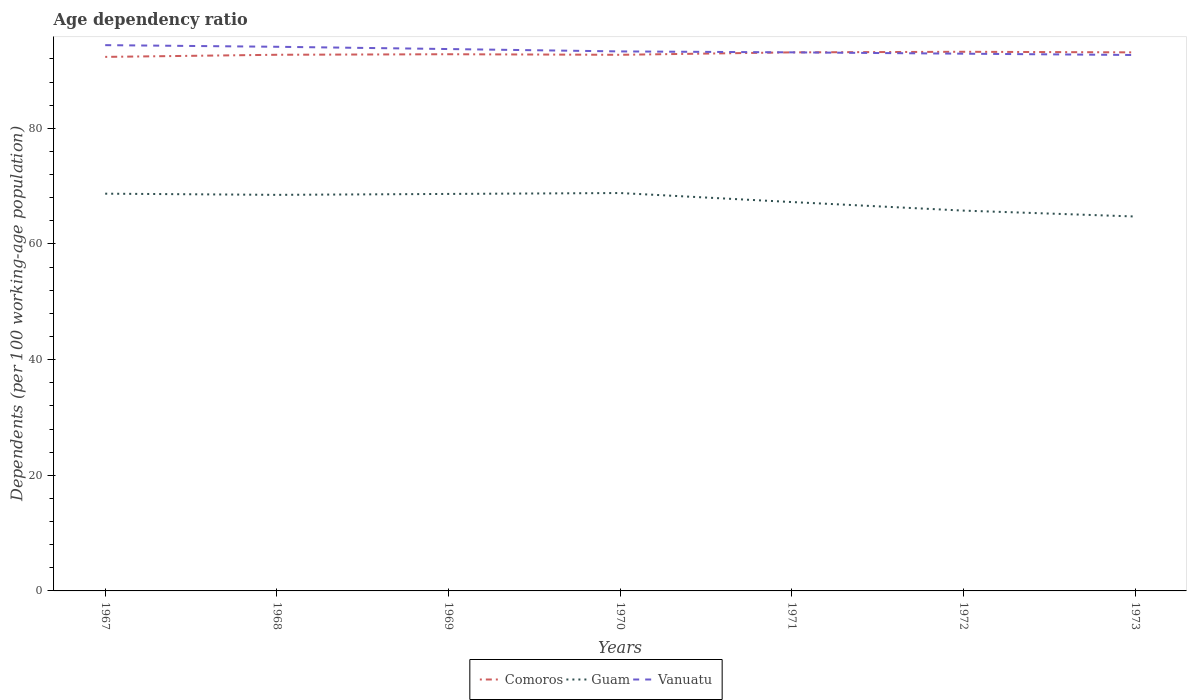How many different coloured lines are there?
Your answer should be compact. 3. Does the line corresponding to Comoros intersect with the line corresponding to Guam?
Offer a very short reply. No. Is the number of lines equal to the number of legend labels?
Offer a very short reply. Yes. Across all years, what is the maximum age dependency ratio in in Vanuatu?
Your response must be concise. 92.67. In which year was the age dependency ratio in in Vanuatu maximum?
Ensure brevity in your answer.  1973. What is the total age dependency ratio in in Guam in the graph?
Keep it short and to the point. 1.24. What is the difference between the highest and the second highest age dependency ratio in in Guam?
Offer a terse response. 4.06. How many years are there in the graph?
Your answer should be very brief. 7. Are the values on the major ticks of Y-axis written in scientific E-notation?
Ensure brevity in your answer.  No. Does the graph contain grids?
Give a very brief answer. No. What is the title of the graph?
Offer a very short reply. Age dependency ratio. Does "Norway" appear as one of the legend labels in the graph?
Your answer should be compact. No. What is the label or title of the X-axis?
Make the answer very short. Years. What is the label or title of the Y-axis?
Offer a terse response. Dependents (per 100 working-age population). What is the Dependents (per 100 working-age population) of Comoros in 1967?
Give a very brief answer. 92.35. What is the Dependents (per 100 working-age population) of Guam in 1967?
Make the answer very short. 68.69. What is the Dependents (per 100 working-age population) in Vanuatu in 1967?
Give a very brief answer. 94.38. What is the Dependents (per 100 working-age population) in Comoros in 1968?
Provide a short and direct response. 92.72. What is the Dependents (per 100 working-age population) in Guam in 1968?
Your answer should be very brief. 68.49. What is the Dependents (per 100 working-age population) in Vanuatu in 1968?
Your response must be concise. 94.1. What is the Dependents (per 100 working-age population) in Comoros in 1969?
Offer a very short reply. 92.81. What is the Dependents (per 100 working-age population) in Guam in 1969?
Ensure brevity in your answer.  68.65. What is the Dependents (per 100 working-age population) of Vanuatu in 1969?
Your answer should be very brief. 93.71. What is the Dependents (per 100 working-age population) in Comoros in 1970?
Provide a short and direct response. 92.71. What is the Dependents (per 100 working-age population) of Guam in 1970?
Offer a very short reply. 68.81. What is the Dependents (per 100 working-age population) of Vanuatu in 1970?
Your response must be concise. 93.29. What is the Dependents (per 100 working-age population) of Comoros in 1971?
Your response must be concise. 93.13. What is the Dependents (per 100 working-age population) of Guam in 1971?
Provide a succinct answer. 67.25. What is the Dependents (per 100 working-age population) of Vanuatu in 1971?
Offer a very short reply. 93.13. What is the Dependents (per 100 working-age population) in Comoros in 1972?
Ensure brevity in your answer.  93.23. What is the Dependents (per 100 working-age population) in Guam in 1972?
Keep it short and to the point. 65.77. What is the Dependents (per 100 working-age population) in Vanuatu in 1972?
Keep it short and to the point. 92.9. What is the Dependents (per 100 working-age population) in Comoros in 1973?
Keep it short and to the point. 93.13. What is the Dependents (per 100 working-age population) in Guam in 1973?
Offer a terse response. 64.75. What is the Dependents (per 100 working-age population) of Vanuatu in 1973?
Your answer should be compact. 92.67. Across all years, what is the maximum Dependents (per 100 working-age population) of Comoros?
Offer a very short reply. 93.23. Across all years, what is the maximum Dependents (per 100 working-age population) in Guam?
Provide a short and direct response. 68.81. Across all years, what is the maximum Dependents (per 100 working-age population) in Vanuatu?
Keep it short and to the point. 94.38. Across all years, what is the minimum Dependents (per 100 working-age population) in Comoros?
Ensure brevity in your answer.  92.35. Across all years, what is the minimum Dependents (per 100 working-age population) in Guam?
Keep it short and to the point. 64.75. Across all years, what is the minimum Dependents (per 100 working-age population) in Vanuatu?
Keep it short and to the point. 92.67. What is the total Dependents (per 100 working-age population) of Comoros in the graph?
Your answer should be compact. 650.08. What is the total Dependents (per 100 working-age population) in Guam in the graph?
Keep it short and to the point. 472.41. What is the total Dependents (per 100 working-age population) of Vanuatu in the graph?
Offer a terse response. 654.19. What is the difference between the Dependents (per 100 working-age population) in Comoros in 1967 and that in 1968?
Make the answer very short. -0.37. What is the difference between the Dependents (per 100 working-age population) of Guam in 1967 and that in 1968?
Offer a very short reply. 0.2. What is the difference between the Dependents (per 100 working-age population) of Vanuatu in 1967 and that in 1968?
Make the answer very short. 0.28. What is the difference between the Dependents (per 100 working-age population) of Comoros in 1967 and that in 1969?
Provide a short and direct response. -0.46. What is the difference between the Dependents (per 100 working-age population) of Guam in 1967 and that in 1969?
Provide a short and direct response. 0.04. What is the difference between the Dependents (per 100 working-age population) in Vanuatu in 1967 and that in 1969?
Your answer should be very brief. 0.67. What is the difference between the Dependents (per 100 working-age population) of Comoros in 1967 and that in 1970?
Keep it short and to the point. -0.36. What is the difference between the Dependents (per 100 working-age population) in Guam in 1967 and that in 1970?
Provide a succinct answer. -0.11. What is the difference between the Dependents (per 100 working-age population) of Vanuatu in 1967 and that in 1970?
Make the answer very short. 1.09. What is the difference between the Dependents (per 100 working-age population) in Comoros in 1967 and that in 1971?
Your response must be concise. -0.78. What is the difference between the Dependents (per 100 working-age population) of Guam in 1967 and that in 1971?
Give a very brief answer. 1.45. What is the difference between the Dependents (per 100 working-age population) of Vanuatu in 1967 and that in 1971?
Provide a succinct answer. 1.25. What is the difference between the Dependents (per 100 working-age population) in Comoros in 1967 and that in 1972?
Keep it short and to the point. -0.88. What is the difference between the Dependents (per 100 working-age population) of Guam in 1967 and that in 1972?
Your answer should be compact. 2.93. What is the difference between the Dependents (per 100 working-age population) of Vanuatu in 1967 and that in 1972?
Give a very brief answer. 1.48. What is the difference between the Dependents (per 100 working-age population) in Comoros in 1967 and that in 1973?
Make the answer very short. -0.78. What is the difference between the Dependents (per 100 working-age population) of Guam in 1967 and that in 1973?
Your response must be concise. 3.95. What is the difference between the Dependents (per 100 working-age population) in Vanuatu in 1967 and that in 1973?
Your answer should be compact. 1.71. What is the difference between the Dependents (per 100 working-age population) in Comoros in 1968 and that in 1969?
Your response must be concise. -0.09. What is the difference between the Dependents (per 100 working-age population) in Guam in 1968 and that in 1969?
Make the answer very short. -0.16. What is the difference between the Dependents (per 100 working-age population) of Vanuatu in 1968 and that in 1969?
Keep it short and to the point. 0.39. What is the difference between the Dependents (per 100 working-age population) of Comoros in 1968 and that in 1970?
Offer a very short reply. 0.01. What is the difference between the Dependents (per 100 working-age population) of Guam in 1968 and that in 1970?
Give a very brief answer. -0.31. What is the difference between the Dependents (per 100 working-age population) of Vanuatu in 1968 and that in 1970?
Offer a terse response. 0.8. What is the difference between the Dependents (per 100 working-age population) of Comoros in 1968 and that in 1971?
Offer a terse response. -0.42. What is the difference between the Dependents (per 100 working-age population) of Guam in 1968 and that in 1971?
Give a very brief answer. 1.24. What is the difference between the Dependents (per 100 working-age population) of Vanuatu in 1968 and that in 1971?
Offer a terse response. 0.96. What is the difference between the Dependents (per 100 working-age population) in Comoros in 1968 and that in 1972?
Provide a short and direct response. -0.52. What is the difference between the Dependents (per 100 working-age population) of Guam in 1968 and that in 1972?
Your answer should be compact. 2.72. What is the difference between the Dependents (per 100 working-age population) in Vanuatu in 1968 and that in 1972?
Keep it short and to the point. 1.2. What is the difference between the Dependents (per 100 working-age population) of Comoros in 1968 and that in 1973?
Ensure brevity in your answer.  -0.41. What is the difference between the Dependents (per 100 working-age population) of Guam in 1968 and that in 1973?
Ensure brevity in your answer.  3.74. What is the difference between the Dependents (per 100 working-age population) in Vanuatu in 1968 and that in 1973?
Keep it short and to the point. 1.42. What is the difference between the Dependents (per 100 working-age population) in Comoros in 1969 and that in 1970?
Offer a terse response. 0.1. What is the difference between the Dependents (per 100 working-age population) of Guam in 1969 and that in 1970?
Keep it short and to the point. -0.16. What is the difference between the Dependents (per 100 working-age population) in Vanuatu in 1969 and that in 1970?
Offer a very short reply. 0.41. What is the difference between the Dependents (per 100 working-age population) of Comoros in 1969 and that in 1971?
Give a very brief answer. -0.32. What is the difference between the Dependents (per 100 working-age population) in Guam in 1969 and that in 1971?
Provide a short and direct response. 1.4. What is the difference between the Dependents (per 100 working-age population) of Vanuatu in 1969 and that in 1971?
Provide a short and direct response. 0.57. What is the difference between the Dependents (per 100 working-age population) in Comoros in 1969 and that in 1972?
Ensure brevity in your answer.  -0.42. What is the difference between the Dependents (per 100 working-age population) in Guam in 1969 and that in 1972?
Offer a very short reply. 2.88. What is the difference between the Dependents (per 100 working-age population) of Vanuatu in 1969 and that in 1972?
Your response must be concise. 0.8. What is the difference between the Dependents (per 100 working-age population) of Comoros in 1969 and that in 1973?
Your response must be concise. -0.32. What is the difference between the Dependents (per 100 working-age population) of Guam in 1969 and that in 1973?
Your answer should be very brief. 3.9. What is the difference between the Dependents (per 100 working-age population) in Vanuatu in 1969 and that in 1973?
Your response must be concise. 1.03. What is the difference between the Dependents (per 100 working-age population) of Comoros in 1970 and that in 1971?
Your response must be concise. -0.42. What is the difference between the Dependents (per 100 working-age population) in Guam in 1970 and that in 1971?
Give a very brief answer. 1.56. What is the difference between the Dependents (per 100 working-age population) in Vanuatu in 1970 and that in 1971?
Provide a short and direct response. 0.16. What is the difference between the Dependents (per 100 working-age population) of Comoros in 1970 and that in 1972?
Provide a succinct answer. -0.52. What is the difference between the Dependents (per 100 working-age population) in Guam in 1970 and that in 1972?
Provide a short and direct response. 3.04. What is the difference between the Dependents (per 100 working-age population) of Vanuatu in 1970 and that in 1972?
Your answer should be very brief. 0.39. What is the difference between the Dependents (per 100 working-age population) of Comoros in 1970 and that in 1973?
Make the answer very short. -0.42. What is the difference between the Dependents (per 100 working-age population) of Guam in 1970 and that in 1973?
Give a very brief answer. 4.06. What is the difference between the Dependents (per 100 working-age population) in Vanuatu in 1970 and that in 1973?
Give a very brief answer. 0.62. What is the difference between the Dependents (per 100 working-age population) in Comoros in 1971 and that in 1972?
Keep it short and to the point. -0.1. What is the difference between the Dependents (per 100 working-age population) of Guam in 1971 and that in 1972?
Keep it short and to the point. 1.48. What is the difference between the Dependents (per 100 working-age population) in Vanuatu in 1971 and that in 1972?
Make the answer very short. 0.23. What is the difference between the Dependents (per 100 working-age population) in Guam in 1971 and that in 1973?
Keep it short and to the point. 2.5. What is the difference between the Dependents (per 100 working-age population) in Vanuatu in 1971 and that in 1973?
Offer a very short reply. 0.46. What is the difference between the Dependents (per 100 working-age population) of Comoros in 1972 and that in 1973?
Your answer should be very brief. 0.1. What is the difference between the Dependents (per 100 working-age population) in Guam in 1972 and that in 1973?
Offer a very short reply. 1.02. What is the difference between the Dependents (per 100 working-age population) in Vanuatu in 1972 and that in 1973?
Provide a short and direct response. 0.23. What is the difference between the Dependents (per 100 working-age population) in Comoros in 1967 and the Dependents (per 100 working-age population) in Guam in 1968?
Your response must be concise. 23.86. What is the difference between the Dependents (per 100 working-age population) in Comoros in 1967 and the Dependents (per 100 working-age population) in Vanuatu in 1968?
Your answer should be compact. -1.75. What is the difference between the Dependents (per 100 working-age population) of Guam in 1967 and the Dependents (per 100 working-age population) of Vanuatu in 1968?
Your response must be concise. -25.4. What is the difference between the Dependents (per 100 working-age population) in Comoros in 1967 and the Dependents (per 100 working-age population) in Guam in 1969?
Give a very brief answer. 23.7. What is the difference between the Dependents (per 100 working-age population) in Comoros in 1967 and the Dependents (per 100 working-age population) in Vanuatu in 1969?
Your response must be concise. -1.36. What is the difference between the Dependents (per 100 working-age population) in Guam in 1967 and the Dependents (per 100 working-age population) in Vanuatu in 1969?
Give a very brief answer. -25.01. What is the difference between the Dependents (per 100 working-age population) of Comoros in 1967 and the Dependents (per 100 working-age population) of Guam in 1970?
Make the answer very short. 23.54. What is the difference between the Dependents (per 100 working-age population) of Comoros in 1967 and the Dependents (per 100 working-age population) of Vanuatu in 1970?
Your answer should be compact. -0.95. What is the difference between the Dependents (per 100 working-age population) of Guam in 1967 and the Dependents (per 100 working-age population) of Vanuatu in 1970?
Offer a very short reply. -24.6. What is the difference between the Dependents (per 100 working-age population) in Comoros in 1967 and the Dependents (per 100 working-age population) in Guam in 1971?
Ensure brevity in your answer.  25.1. What is the difference between the Dependents (per 100 working-age population) of Comoros in 1967 and the Dependents (per 100 working-age population) of Vanuatu in 1971?
Ensure brevity in your answer.  -0.79. What is the difference between the Dependents (per 100 working-age population) in Guam in 1967 and the Dependents (per 100 working-age population) in Vanuatu in 1971?
Offer a terse response. -24.44. What is the difference between the Dependents (per 100 working-age population) of Comoros in 1967 and the Dependents (per 100 working-age population) of Guam in 1972?
Your answer should be compact. 26.58. What is the difference between the Dependents (per 100 working-age population) in Comoros in 1967 and the Dependents (per 100 working-age population) in Vanuatu in 1972?
Make the answer very short. -0.55. What is the difference between the Dependents (per 100 working-age population) of Guam in 1967 and the Dependents (per 100 working-age population) of Vanuatu in 1972?
Provide a succinct answer. -24.21. What is the difference between the Dependents (per 100 working-age population) in Comoros in 1967 and the Dependents (per 100 working-age population) in Guam in 1973?
Your response must be concise. 27.6. What is the difference between the Dependents (per 100 working-age population) of Comoros in 1967 and the Dependents (per 100 working-age population) of Vanuatu in 1973?
Keep it short and to the point. -0.33. What is the difference between the Dependents (per 100 working-age population) in Guam in 1967 and the Dependents (per 100 working-age population) in Vanuatu in 1973?
Keep it short and to the point. -23.98. What is the difference between the Dependents (per 100 working-age population) of Comoros in 1968 and the Dependents (per 100 working-age population) of Guam in 1969?
Make the answer very short. 24.06. What is the difference between the Dependents (per 100 working-age population) in Comoros in 1968 and the Dependents (per 100 working-age population) in Vanuatu in 1969?
Your answer should be very brief. -0.99. What is the difference between the Dependents (per 100 working-age population) of Guam in 1968 and the Dependents (per 100 working-age population) of Vanuatu in 1969?
Give a very brief answer. -25.21. What is the difference between the Dependents (per 100 working-age population) in Comoros in 1968 and the Dependents (per 100 working-age population) in Guam in 1970?
Make the answer very short. 23.91. What is the difference between the Dependents (per 100 working-age population) in Comoros in 1968 and the Dependents (per 100 working-age population) in Vanuatu in 1970?
Ensure brevity in your answer.  -0.58. What is the difference between the Dependents (per 100 working-age population) of Guam in 1968 and the Dependents (per 100 working-age population) of Vanuatu in 1970?
Give a very brief answer. -24.8. What is the difference between the Dependents (per 100 working-age population) of Comoros in 1968 and the Dependents (per 100 working-age population) of Guam in 1971?
Provide a succinct answer. 25.47. What is the difference between the Dependents (per 100 working-age population) in Comoros in 1968 and the Dependents (per 100 working-age population) in Vanuatu in 1971?
Keep it short and to the point. -0.42. What is the difference between the Dependents (per 100 working-age population) of Guam in 1968 and the Dependents (per 100 working-age population) of Vanuatu in 1971?
Provide a succinct answer. -24.64. What is the difference between the Dependents (per 100 working-age population) in Comoros in 1968 and the Dependents (per 100 working-age population) in Guam in 1972?
Provide a succinct answer. 26.95. What is the difference between the Dependents (per 100 working-age population) in Comoros in 1968 and the Dependents (per 100 working-age population) in Vanuatu in 1972?
Ensure brevity in your answer.  -0.19. What is the difference between the Dependents (per 100 working-age population) of Guam in 1968 and the Dependents (per 100 working-age population) of Vanuatu in 1972?
Give a very brief answer. -24.41. What is the difference between the Dependents (per 100 working-age population) in Comoros in 1968 and the Dependents (per 100 working-age population) in Guam in 1973?
Your answer should be compact. 27.97. What is the difference between the Dependents (per 100 working-age population) of Comoros in 1968 and the Dependents (per 100 working-age population) of Vanuatu in 1973?
Make the answer very short. 0.04. What is the difference between the Dependents (per 100 working-age population) of Guam in 1968 and the Dependents (per 100 working-age population) of Vanuatu in 1973?
Your answer should be compact. -24.18. What is the difference between the Dependents (per 100 working-age population) in Comoros in 1969 and the Dependents (per 100 working-age population) in Guam in 1970?
Your answer should be very brief. 24. What is the difference between the Dependents (per 100 working-age population) in Comoros in 1969 and the Dependents (per 100 working-age population) in Vanuatu in 1970?
Keep it short and to the point. -0.49. What is the difference between the Dependents (per 100 working-age population) of Guam in 1969 and the Dependents (per 100 working-age population) of Vanuatu in 1970?
Make the answer very short. -24.64. What is the difference between the Dependents (per 100 working-age population) in Comoros in 1969 and the Dependents (per 100 working-age population) in Guam in 1971?
Your answer should be compact. 25.56. What is the difference between the Dependents (per 100 working-age population) of Comoros in 1969 and the Dependents (per 100 working-age population) of Vanuatu in 1971?
Your answer should be very brief. -0.33. What is the difference between the Dependents (per 100 working-age population) in Guam in 1969 and the Dependents (per 100 working-age population) in Vanuatu in 1971?
Your answer should be compact. -24.48. What is the difference between the Dependents (per 100 working-age population) of Comoros in 1969 and the Dependents (per 100 working-age population) of Guam in 1972?
Your answer should be very brief. 27.04. What is the difference between the Dependents (per 100 working-age population) in Comoros in 1969 and the Dependents (per 100 working-age population) in Vanuatu in 1972?
Offer a very short reply. -0.09. What is the difference between the Dependents (per 100 working-age population) of Guam in 1969 and the Dependents (per 100 working-age population) of Vanuatu in 1972?
Offer a terse response. -24.25. What is the difference between the Dependents (per 100 working-age population) in Comoros in 1969 and the Dependents (per 100 working-age population) in Guam in 1973?
Make the answer very short. 28.06. What is the difference between the Dependents (per 100 working-age population) of Comoros in 1969 and the Dependents (per 100 working-age population) of Vanuatu in 1973?
Provide a succinct answer. 0.13. What is the difference between the Dependents (per 100 working-age population) of Guam in 1969 and the Dependents (per 100 working-age population) of Vanuatu in 1973?
Give a very brief answer. -24.02. What is the difference between the Dependents (per 100 working-age population) of Comoros in 1970 and the Dependents (per 100 working-age population) of Guam in 1971?
Ensure brevity in your answer.  25.46. What is the difference between the Dependents (per 100 working-age population) of Comoros in 1970 and the Dependents (per 100 working-age population) of Vanuatu in 1971?
Make the answer very short. -0.43. What is the difference between the Dependents (per 100 working-age population) in Guam in 1970 and the Dependents (per 100 working-age population) in Vanuatu in 1971?
Your answer should be very brief. -24.33. What is the difference between the Dependents (per 100 working-age population) in Comoros in 1970 and the Dependents (per 100 working-age population) in Guam in 1972?
Your response must be concise. 26.94. What is the difference between the Dependents (per 100 working-age population) in Comoros in 1970 and the Dependents (per 100 working-age population) in Vanuatu in 1972?
Your answer should be compact. -0.19. What is the difference between the Dependents (per 100 working-age population) in Guam in 1970 and the Dependents (per 100 working-age population) in Vanuatu in 1972?
Ensure brevity in your answer.  -24.1. What is the difference between the Dependents (per 100 working-age population) in Comoros in 1970 and the Dependents (per 100 working-age population) in Guam in 1973?
Your response must be concise. 27.96. What is the difference between the Dependents (per 100 working-age population) of Comoros in 1970 and the Dependents (per 100 working-age population) of Vanuatu in 1973?
Your response must be concise. 0.03. What is the difference between the Dependents (per 100 working-age population) of Guam in 1970 and the Dependents (per 100 working-age population) of Vanuatu in 1973?
Give a very brief answer. -23.87. What is the difference between the Dependents (per 100 working-age population) of Comoros in 1971 and the Dependents (per 100 working-age population) of Guam in 1972?
Provide a succinct answer. 27.36. What is the difference between the Dependents (per 100 working-age population) in Comoros in 1971 and the Dependents (per 100 working-age population) in Vanuatu in 1972?
Offer a terse response. 0.23. What is the difference between the Dependents (per 100 working-age population) of Guam in 1971 and the Dependents (per 100 working-age population) of Vanuatu in 1972?
Provide a short and direct response. -25.65. What is the difference between the Dependents (per 100 working-age population) of Comoros in 1971 and the Dependents (per 100 working-age population) of Guam in 1973?
Provide a succinct answer. 28.38. What is the difference between the Dependents (per 100 working-age population) in Comoros in 1971 and the Dependents (per 100 working-age population) in Vanuatu in 1973?
Your answer should be very brief. 0.46. What is the difference between the Dependents (per 100 working-age population) in Guam in 1971 and the Dependents (per 100 working-age population) in Vanuatu in 1973?
Your response must be concise. -25.43. What is the difference between the Dependents (per 100 working-age population) in Comoros in 1972 and the Dependents (per 100 working-age population) in Guam in 1973?
Give a very brief answer. 28.49. What is the difference between the Dependents (per 100 working-age population) of Comoros in 1972 and the Dependents (per 100 working-age population) of Vanuatu in 1973?
Offer a very short reply. 0.56. What is the difference between the Dependents (per 100 working-age population) of Guam in 1972 and the Dependents (per 100 working-age population) of Vanuatu in 1973?
Keep it short and to the point. -26.91. What is the average Dependents (per 100 working-age population) of Comoros per year?
Give a very brief answer. 92.87. What is the average Dependents (per 100 working-age population) of Guam per year?
Offer a very short reply. 67.49. What is the average Dependents (per 100 working-age population) in Vanuatu per year?
Your answer should be compact. 93.46. In the year 1967, what is the difference between the Dependents (per 100 working-age population) of Comoros and Dependents (per 100 working-age population) of Guam?
Keep it short and to the point. 23.65. In the year 1967, what is the difference between the Dependents (per 100 working-age population) of Comoros and Dependents (per 100 working-age population) of Vanuatu?
Your answer should be very brief. -2.03. In the year 1967, what is the difference between the Dependents (per 100 working-age population) of Guam and Dependents (per 100 working-age population) of Vanuatu?
Your answer should be compact. -25.69. In the year 1968, what is the difference between the Dependents (per 100 working-age population) in Comoros and Dependents (per 100 working-age population) in Guam?
Keep it short and to the point. 24.22. In the year 1968, what is the difference between the Dependents (per 100 working-age population) of Comoros and Dependents (per 100 working-age population) of Vanuatu?
Your response must be concise. -1.38. In the year 1968, what is the difference between the Dependents (per 100 working-age population) in Guam and Dependents (per 100 working-age population) in Vanuatu?
Your response must be concise. -25.61. In the year 1969, what is the difference between the Dependents (per 100 working-age population) of Comoros and Dependents (per 100 working-age population) of Guam?
Ensure brevity in your answer.  24.16. In the year 1969, what is the difference between the Dependents (per 100 working-age population) in Comoros and Dependents (per 100 working-age population) in Vanuatu?
Ensure brevity in your answer.  -0.9. In the year 1969, what is the difference between the Dependents (per 100 working-age population) in Guam and Dependents (per 100 working-age population) in Vanuatu?
Offer a terse response. -25.05. In the year 1970, what is the difference between the Dependents (per 100 working-age population) in Comoros and Dependents (per 100 working-age population) in Guam?
Provide a succinct answer. 23.9. In the year 1970, what is the difference between the Dependents (per 100 working-age population) of Comoros and Dependents (per 100 working-age population) of Vanuatu?
Provide a short and direct response. -0.59. In the year 1970, what is the difference between the Dependents (per 100 working-age population) of Guam and Dependents (per 100 working-age population) of Vanuatu?
Ensure brevity in your answer.  -24.49. In the year 1971, what is the difference between the Dependents (per 100 working-age population) of Comoros and Dependents (per 100 working-age population) of Guam?
Provide a short and direct response. 25.88. In the year 1971, what is the difference between the Dependents (per 100 working-age population) in Comoros and Dependents (per 100 working-age population) in Vanuatu?
Give a very brief answer. -0. In the year 1971, what is the difference between the Dependents (per 100 working-age population) in Guam and Dependents (per 100 working-age population) in Vanuatu?
Make the answer very short. -25.89. In the year 1972, what is the difference between the Dependents (per 100 working-age population) of Comoros and Dependents (per 100 working-age population) of Guam?
Make the answer very short. 27.47. In the year 1972, what is the difference between the Dependents (per 100 working-age population) of Comoros and Dependents (per 100 working-age population) of Vanuatu?
Make the answer very short. 0.33. In the year 1972, what is the difference between the Dependents (per 100 working-age population) in Guam and Dependents (per 100 working-age population) in Vanuatu?
Offer a terse response. -27.13. In the year 1973, what is the difference between the Dependents (per 100 working-age population) in Comoros and Dependents (per 100 working-age population) in Guam?
Make the answer very short. 28.38. In the year 1973, what is the difference between the Dependents (per 100 working-age population) of Comoros and Dependents (per 100 working-age population) of Vanuatu?
Keep it short and to the point. 0.46. In the year 1973, what is the difference between the Dependents (per 100 working-age population) in Guam and Dependents (per 100 working-age population) in Vanuatu?
Your answer should be very brief. -27.93. What is the ratio of the Dependents (per 100 working-age population) in Comoros in 1967 to that in 1970?
Keep it short and to the point. 1. What is the ratio of the Dependents (per 100 working-age population) of Vanuatu in 1967 to that in 1970?
Give a very brief answer. 1.01. What is the ratio of the Dependents (per 100 working-age population) of Comoros in 1967 to that in 1971?
Your response must be concise. 0.99. What is the ratio of the Dependents (per 100 working-age population) of Guam in 1967 to that in 1971?
Give a very brief answer. 1.02. What is the ratio of the Dependents (per 100 working-age population) in Vanuatu in 1967 to that in 1971?
Ensure brevity in your answer.  1.01. What is the ratio of the Dependents (per 100 working-age population) in Comoros in 1967 to that in 1972?
Offer a terse response. 0.99. What is the ratio of the Dependents (per 100 working-age population) of Guam in 1967 to that in 1972?
Your answer should be compact. 1.04. What is the ratio of the Dependents (per 100 working-age population) of Vanuatu in 1967 to that in 1972?
Offer a terse response. 1.02. What is the ratio of the Dependents (per 100 working-age population) of Comoros in 1967 to that in 1973?
Provide a short and direct response. 0.99. What is the ratio of the Dependents (per 100 working-age population) of Guam in 1967 to that in 1973?
Your answer should be compact. 1.06. What is the ratio of the Dependents (per 100 working-age population) in Vanuatu in 1967 to that in 1973?
Your answer should be very brief. 1.02. What is the ratio of the Dependents (per 100 working-age population) in Vanuatu in 1968 to that in 1969?
Ensure brevity in your answer.  1. What is the ratio of the Dependents (per 100 working-age population) of Comoros in 1968 to that in 1970?
Ensure brevity in your answer.  1. What is the ratio of the Dependents (per 100 working-age population) in Guam in 1968 to that in 1970?
Your answer should be very brief. 1. What is the ratio of the Dependents (per 100 working-age population) in Vanuatu in 1968 to that in 1970?
Give a very brief answer. 1.01. What is the ratio of the Dependents (per 100 working-age population) of Comoros in 1968 to that in 1971?
Your answer should be compact. 1. What is the ratio of the Dependents (per 100 working-age population) of Guam in 1968 to that in 1971?
Provide a succinct answer. 1.02. What is the ratio of the Dependents (per 100 working-age population) in Vanuatu in 1968 to that in 1971?
Offer a terse response. 1.01. What is the ratio of the Dependents (per 100 working-age population) of Comoros in 1968 to that in 1972?
Your response must be concise. 0.99. What is the ratio of the Dependents (per 100 working-age population) in Guam in 1968 to that in 1972?
Provide a short and direct response. 1.04. What is the ratio of the Dependents (per 100 working-age population) of Vanuatu in 1968 to that in 1972?
Give a very brief answer. 1.01. What is the ratio of the Dependents (per 100 working-age population) in Guam in 1968 to that in 1973?
Make the answer very short. 1.06. What is the ratio of the Dependents (per 100 working-age population) in Vanuatu in 1968 to that in 1973?
Your answer should be compact. 1.02. What is the ratio of the Dependents (per 100 working-age population) in Comoros in 1969 to that in 1971?
Offer a terse response. 1. What is the ratio of the Dependents (per 100 working-age population) of Guam in 1969 to that in 1971?
Your answer should be compact. 1.02. What is the ratio of the Dependents (per 100 working-age population) in Guam in 1969 to that in 1972?
Provide a succinct answer. 1.04. What is the ratio of the Dependents (per 100 working-age population) of Vanuatu in 1969 to that in 1972?
Offer a terse response. 1.01. What is the ratio of the Dependents (per 100 working-age population) in Guam in 1969 to that in 1973?
Offer a very short reply. 1.06. What is the ratio of the Dependents (per 100 working-age population) in Vanuatu in 1969 to that in 1973?
Your response must be concise. 1.01. What is the ratio of the Dependents (per 100 working-age population) in Comoros in 1970 to that in 1971?
Offer a terse response. 1. What is the ratio of the Dependents (per 100 working-age population) in Guam in 1970 to that in 1971?
Your answer should be very brief. 1.02. What is the ratio of the Dependents (per 100 working-age population) in Vanuatu in 1970 to that in 1971?
Your answer should be very brief. 1. What is the ratio of the Dependents (per 100 working-age population) in Guam in 1970 to that in 1972?
Offer a terse response. 1.05. What is the ratio of the Dependents (per 100 working-age population) in Guam in 1970 to that in 1973?
Provide a short and direct response. 1.06. What is the ratio of the Dependents (per 100 working-age population) of Vanuatu in 1970 to that in 1973?
Offer a terse response. 1.01. What is the ratio of the Dependents (per 100 working-age population) of Guam in 1971 to that in 1972?
Your answer should be compact. 1.02. What is the ratio of the Dependents (per 100 working-age population) in Comoros in 1971 to that in 1973?
Ensure brevity in your answer.  1. What is the ratio of the Dependents (per 100 working-age population) in Guam in 1971 to that in 1973?
Your answer should be very brief. 1.04. What is the ratio of the Dependents (per 100 working-age population) of Guam in 1972 to that in 1973?
Give a very brief answer. 1.02. What is the difference between the highest and the second highest Dependents (per 100 working-age population) in Comoros?
Provide a succinct answer. 0.1. What is the difference between the highest and the second highest Dependents (per 100 working-age population) in Guam?
Offer a very short reply. 0.11. What is the difference between the highest and the second highest Dependents (per 100 working-age population) of Vanuatu?
Provide a succinct answer. 0.28. What is the difference between the highest and the lowest Dependents (per 100 working-age population) of Comoros?
Provide a succinct answer. 0.88. What is the difference between the highest and the lowest Dependents (per 100 working-age population) in Guam?
Your answer should be compact. 4.06. What is the difference between the highest and the lowest Dependents (per 100 working-age population) of Vanuatu?
Offer a very short reply. 1.71. 